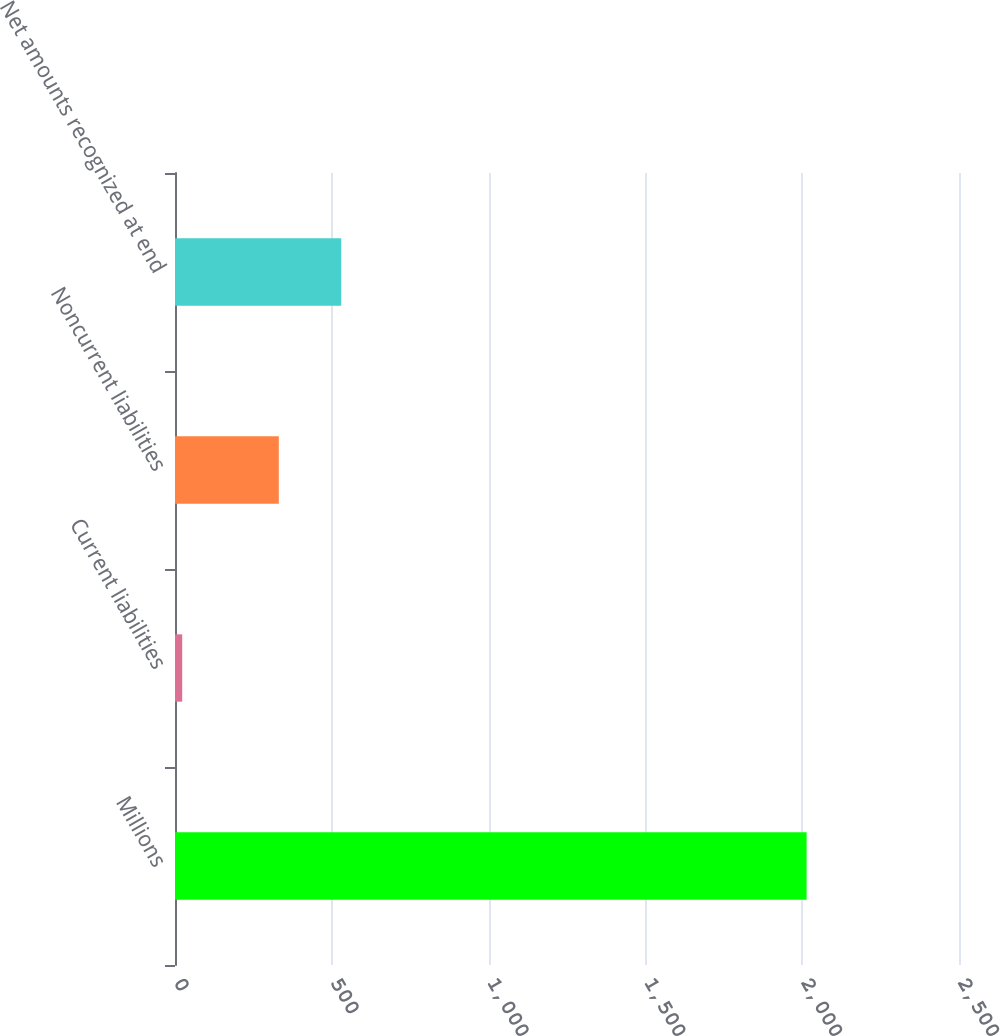Convert chart. <chart><loc_0><loc_0><loc_500><loc_500><bar_chart><fcel>Millions<fcel>Current liabilities<fcel>Noncurrent liabilities<fcel>Net amounts recognized at end<nl><fcel>2014<fcel>23<fcel>331<fcel>530.1<nl></chart> 